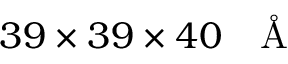<formula> <loc_0><loc_0><loc_500><loc_500>3 9 \times 3 9 \times 4 0 \AA</formula> 